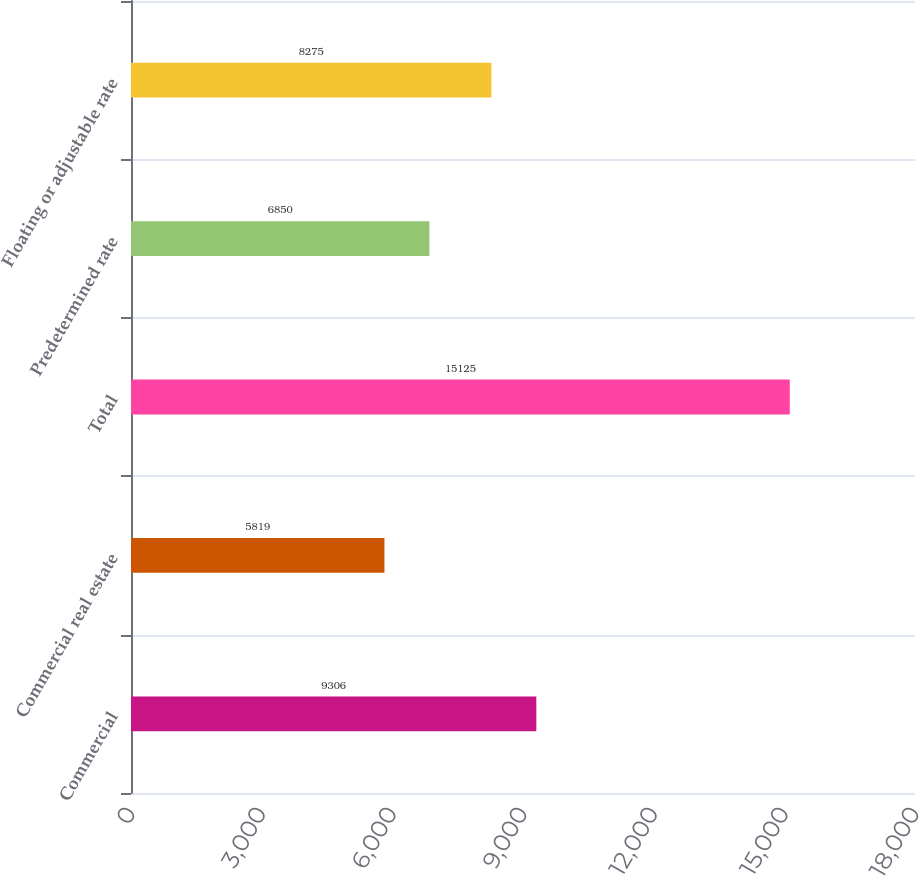Convert chart. <chart><loc_0><loc_0><loc_500><loc_500><bar_chart><fcel>Commercial<fcel>Commercial real estate<fcel>Total<fcel>Predetermined rate<fcel>Floating or adjustable rate<nl><fcel>9306<fcel>5819<fcel>15125<fcel>6850<fcel>8275<nl></chart> 